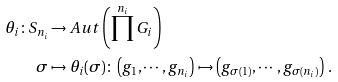Convert formula to latex. <formula><loc_0><loc_0><loc_500><loc_500>\theta _ { i } \colon S _ { n _ { i } } & \rightarrow A u t \left ( \prod ^ { n _ { i } } G _ { i } \right ) \\ \sigma & \mapsto \theta _ { i } ( \sigma ) \colon \left ( g _ { 1 } , \cdots , g _ { n _ { i } } \right ) \mapsto \left ( g _ { \sigma ( 1 ) } , \cdots , g _ { \sigma ( n _ { i } ) } \right ) \, . \\</formula> 